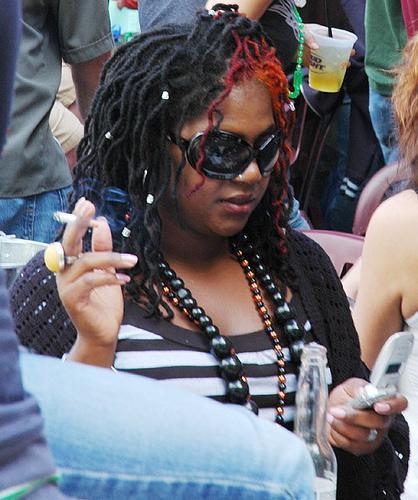How many people are there?
Give a very brief answer. 7. How many sinks are there?
Give a very brief answer. 0. 